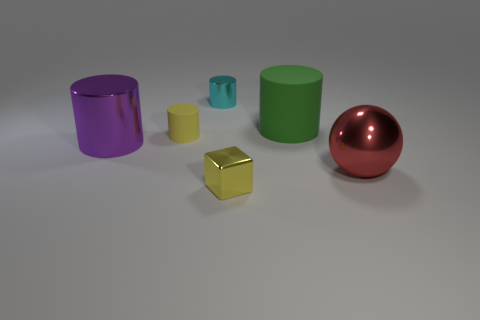Subtract all big green rubber cylinders. How many cylinders are left? 3 Subtract 1 cylinders. How many cylinders are left? 3 Add 4 cyan things. How many objects exist? 10 Subtract all cyan cylinders. How many cylinders are left? 3 Subtract all spheres. How many objects are left? 5 Subtract 0 blue cylinders. How many objects are left? 6 Subtract all green cylinders. Subtract all purple cubes. How many cylinders are left? 3 Subtract all blue cubes. How many purple cylinders are left? 1 Subtract all large metallic balls. Subtract all purple metal cylinders. How many objects are left? 4 Add 3 tiny cyan cylinders. How many tiny cyan cylinders are left? 4 